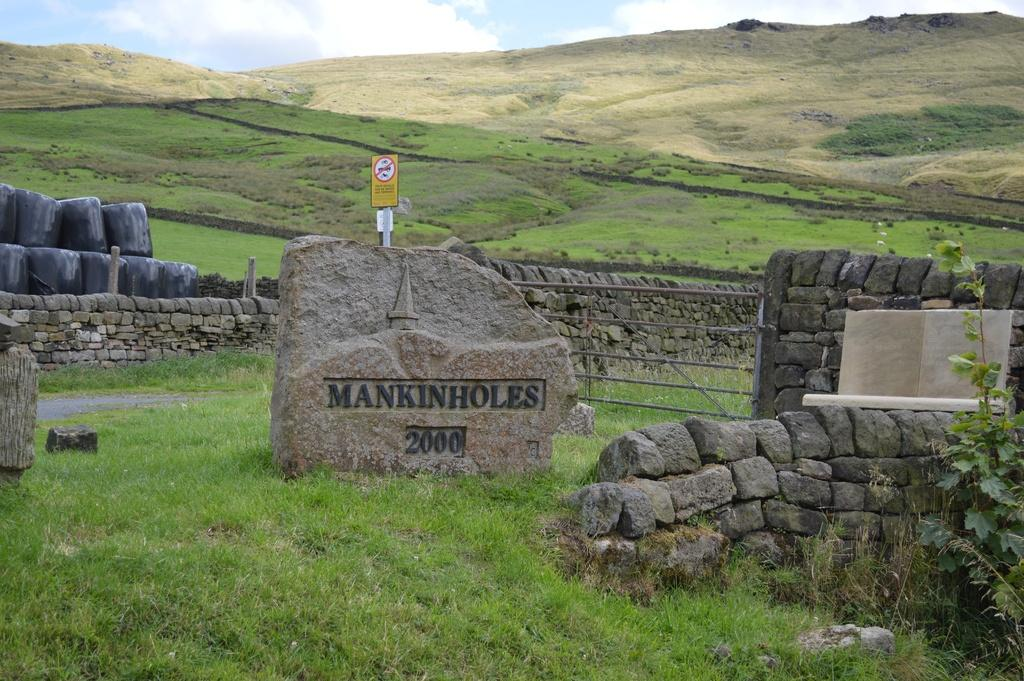What is the main subject in the center of the image? There is a headstone in the center of the image. Where is the headstone located? The headstone is on a grassland. What can be seen behind the headstone? There is a sign pole behind the headstone. What other objects are present in the image? There are stones and greenery in the image. What is visible at the top of the image? The sky is visible at the top of the image. Can you see a lift in the image? No, there is no lift present in the image. What type of beetle can be seen crawling on the headstone? There are no beetles visible in the image; it only features a headstone, grassland, sign pole, stones, greenery, and the sky. 